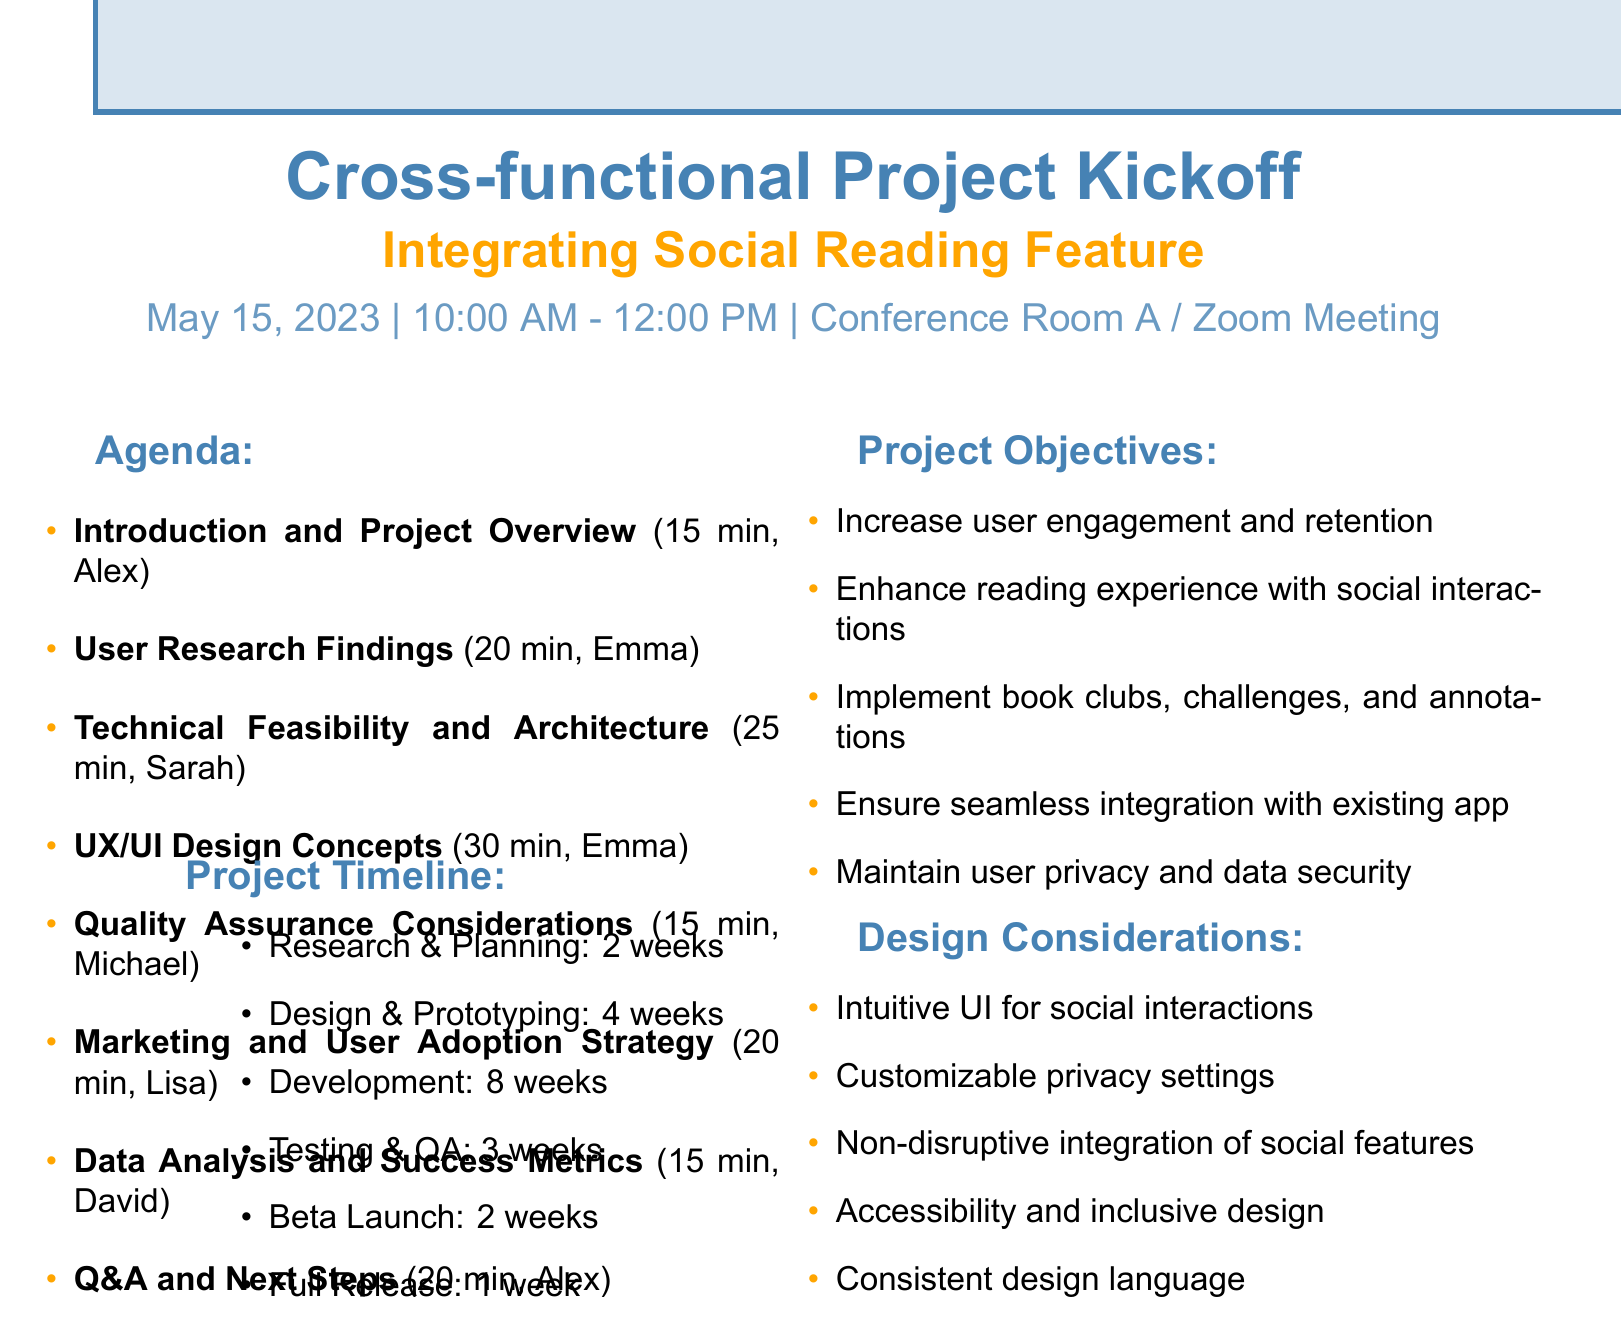What is the date of the meeting? The date of the meeting is specified in the document as May 15, 2023.
Answer: May 15, 2023 Who is the presenter of the UX/UI Design Concepts? This information is retrieved from the agenda items, stating that Emma Thompson is the presenter for the UX/UI Design Concepts.
Answer: Emma Thompson How long is allocated for the User Research Findings presentation? This question refers to the duration specified in the agenda for User Research Findings, which is 20 minutes.
Answer: 20 minutes What is one of the project objectives related to user engagement? This requires connecting the project objectives, where one is increasing user engagement and retention.
Answer: Increase user engagement and retention What is the total duration for the Q&A and Next Steps item? Based on the agenda list, the duration specifically allocated for Q&A and Next Steps is 20 minutes.
Answer: 20 minutes What is the first item listed in the agenda? This concerns the arrangement of items in the agenda; the first item is Introduction and Project Overview.
Answer: Introduction and Project Overview Which presenter is responsible for discussing Technical Feasibility and Architecture? The name associated with this agenda item identifies Sarah Johnson as the presenter for this part.
Answer: Sarah Johnson What is one potential challenge mentioned in the document? Referring to the challenges listed, one potential challenge is ensuring data privacy and compliance with regulations.
Answer: Ensuring data privacy and compliance with regulations 